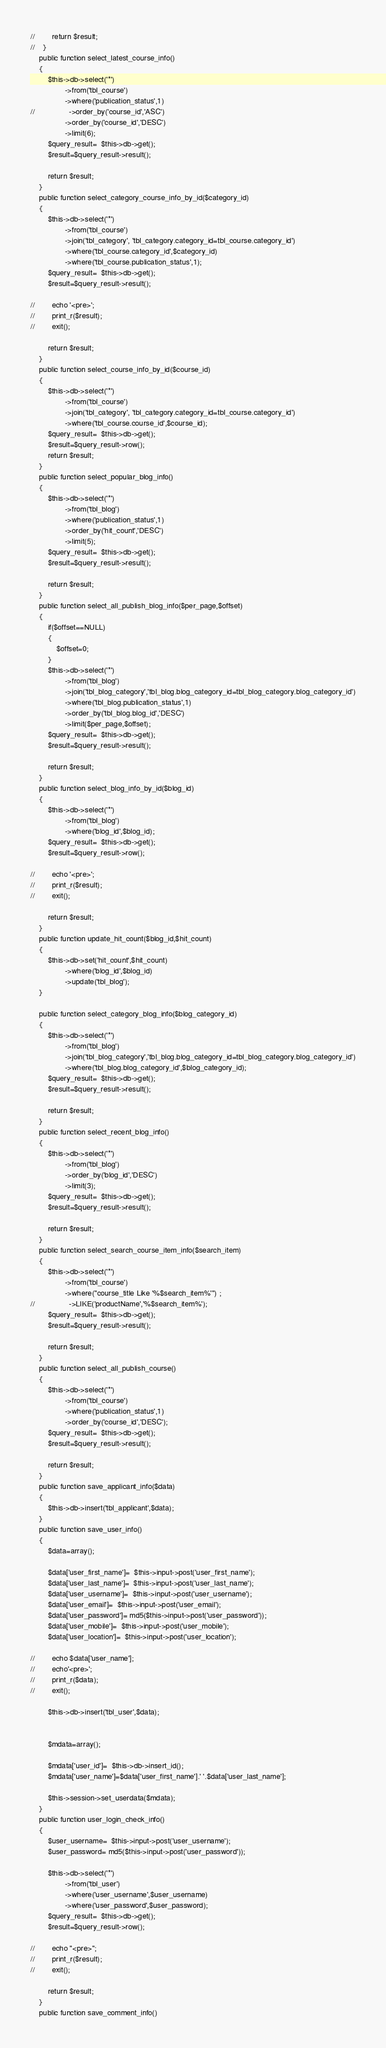Convert code to text. <code><loc_0><loc_0><loc_500><loc_500><_PHP_>//        return $result;
//    }
    public function select_latest_course_info()
    {
        $this->db->select('*')
                ->from('tbl_course')
                ->where('publication_status',1)
//                ->order_by('course_id','ASC')
                ->order_by('course_id','DESC')
                ->limit(6);
        $query_result=  $this->db->get();
        $result=$query_result->result();
        
        return $result;
    }
    public function select_category_course_info_by_id($category_id)
    {
        $this->db->select('*')
                ->from('tbl_course')
                ->join('tbl_category', 'tbl_category.category_id=tbl_course.category_id')
                ->where('tbl_course.category_id',$category_id)
                ->where('tbl_course.publication_status',1);
        $query_result=  $this->db->get();
        $result=$query_result->result();
        
//        echo '<pre>';
//        print_r($result);
//        exit();
        
        return $result;
    }
    public function select_course_info_by_id($course_id)
    {
        $this->db->select('*')
                ->from('tbl_course')
                ->join('tbl_category', 'tbl_category.category_id=tbl_course.category_id')
                ->where('tbl_course.course_id',$course_id);
        $query_result=  $this->db->get();
        $result=$query_result->row();
        return $result;
    }
    public function select_popular_blog_info()
    {
        $this->db->select('*')
                ->from('tbl_blog')
                ->where('publication_status',1)
                ->order_by('hit_count','DESC')
                ->limit(5);
        $query_result=  $this->db->get();
        $result=$query_result->result();
        
        return $result;
    }
    public function select_all_publish_blog_info($per_page,$offset)
    {
        if($offset==NULL)
        {
            $offset=0;
        }
        $this->db->select('*')
                ->from('tbl_blog')
                ->join('tbl_blog_category','tbl_blog.blog_category_id=tbl_blog_category.blog_category_id')
                ->where('tbl_blog.publication_status',1)
                ->order_by('tbl_blog.blog_id','DESC')
                ->limit($per_page,$offset);
        $query_result=  $this->db->get();
        $result=$query_result->result();
        
        return $result;
    }
    public function select_blog_info_by_id($blog_id)
    {
        $this->db->select('*')
                ->from('tbl_blog')
                ->where('blog_id',$blog_id);
        $query_result=  $this->db->get();
        $result=$query_result->row();
        
//        echo '<pre>';
//        print_r($result);
//        exit();
        
        return $result;
    }
    public function update_hit_count($blog_id,$hit_count)
    {
        $this->db->set('hit_count',$hit_count)
                ->where('blog_id',$blog_id)
                ->update('tbl_blog');
    }

    public function select_category_blog_info($blog_category_id)
    {
        $this->db->select('*')
                ->from('tbl_blog')
                ->join('tbl_blog_category','tbl_blog.blog_category_id=tbl_blog_category.blog_category_id')
                ->where('tbl_blog.blog_category_id',$blog_category_id);
        $query_result=  $this->db->get();
        $result=$query_result->result();
        
        return $result;
    }
    public function select_recent_blog_info()
    {
        $this->db->select('*')
                ->from('tbl_blog')
                ->order_by('blog_id','DESC')
                ->limit(3);
        $query_result=  $this->db->get();
        $result=$query_result->result();
        
        return $result;
    }
    public function select_search_course_item_info($search_item)
    {
        $this->db->select('*')
                ->from('tbl_course')
                ->where("course_title Like '%$search_item%'") ;
//                ->LIKE('productName','%$search_item%');
        $query_result=  $this->db->get();
        $result=$query_result->result();
        
        return $result;
    }
    public function select_all_publish_course()
    {
        $this->db->select('*')
                ->from('tbl_course')
                ->where('publication_status',1)
                ->order_by('course_id','DESC');
        $query_result=  $this->db->get();
        $result=$query_result->result();
        
        return $result;
    }
    public function save_applicant_info($data)
    {
        $this->db->insert('tbl_applicant',$data);
    }
    public function save_user_info()
    {
        $data=array();
        
        $data['user_first_name']=  $this->input->post('user_first_name');
        $data['user_last_name']=  $this->input->post('user_last_name');
        $data['user_username']=  $this->input->post('user_username');
        $data['user_email']=  $this->input->post('user_email');
        $data['user_password']= md5($this->input->post('user_password'));
        $data['user_mobile']=  $this->input->post('user_mobile');
        $data['user_location']=  $this->input->post('user_location');
        
//        echo $data['user_name'];
//        echo'<pre>';
//        print_r($data);
//        exit();
        
        $this->db->insert('tbl_user',$data);
        
        
        $mdata=array();
        
        $mdata['user_id']=  $this->db->insert_id();
        $mdata['user_name']=$data['user_first_name'].' '.$data['user_last_name'];
        
        $this->session->set_userdata($mdata);
    }
    public function user_login_check_info()
    {
        $user_username=  $this->input->post('user_username');
        $user_password= md5($this->input->post('user_password'));
        
        $this->db->select('*')
                ->from('tbl_user')
                ->where('user_username',$user_username)
                ->where('user_password',$user_password);
        $query_result=  $this->db->get();
        $result=$query_result->row();
        
//        echo "<pre>";
//        print_r($result);
//        exit();
        
        return $result;
    }
    public function save_comment_info()</code> 